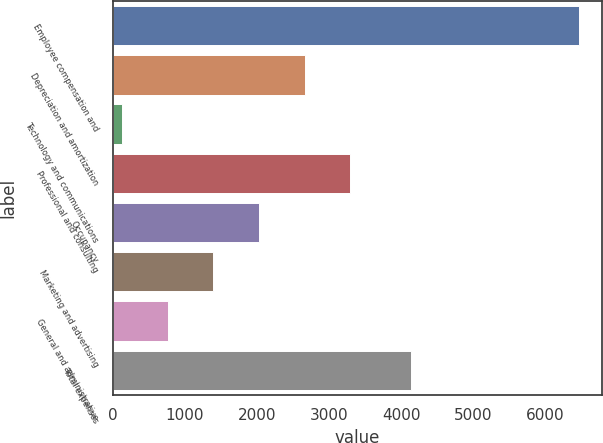Convert chart. <chart><loc_0><loc_0><loc_500><loc_500><bar_chart><fcel>Employee compensation and<fcel>Depreciation and amortization<fcel>Technology and communications<fcel>Professional and consulting<fcel>Occupancy<fcel>Marketing and advertising<fcel>General and administrative<fcel>Total expenses<nl><fcel>6464<fcel>2660.6<fcel>125<fcel>3294.5<fcel>2026.7<fcel>1392.8<fcel>758.9<fcel>4139<nl></chart> 